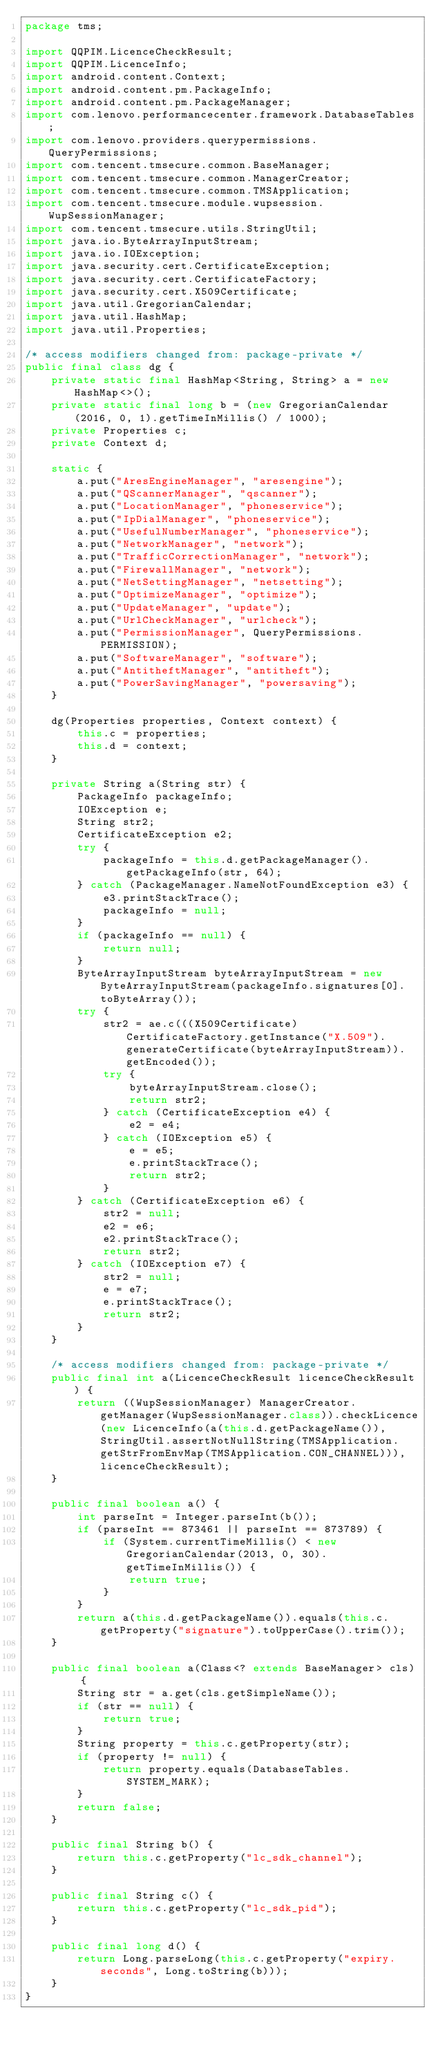Convert code to text. <code><loc_0><loc_0><loc_500><loc_500><_Java_>package tms;

import QQPIM.LicenceCheckResult;
import QQPIM.LicenceInfo;
import android.content.Context;
import android.content.pm.PackageInfo;
import android.content.pm.PackageManager;
import com.lenovo.performancecenter.framework.DatabaseTables;
import com.lenovo.providers.querypermissions.QueryPermissions;
import com.tencent.tmsecure.common.BaseManager;
import com.tencent.tmsecure.common.ManagerCreator;
import com.tencent.tmsecure.common.TMSApplication;
import com.tencent.tmsecure.module.wupsession.WupSessionManager;
import com.tencent.tmsecure.utils.StringUtil;
import java.io.ByteArrayInputStream;
import java.io.IOException;
import java.security.cert.CertificateException;
import java.security.cert.CertificateFactory;
import java.security.cert.X509Certificate;
import java.util.GregorianCalendar;
import java.util.HashMap;
import java.util.Properties;

/* access modifiers changed from: package-private */
public final class dg {
    private static final HashMap<String, String> a = new HashMap<>();
    private static final long b = (new GregorianCalendar(2016, 0, 1).getTimeInMillis() / 1000);
    private Properties c;
    private Context d;

    static {
        a.put("AresEngineManager", "aresengine");
        a.put("QScannerManager", "qscanner");
        a.put("LocationManager", "phoneservice");
        a.put("IpDialManager", "phoneservice");
        a.put("UsefulNumberManager", "phoneservice");
        a.put("NetworkManager", "network");
        a.put("TrafficCorrectionManager", "network");
        a.put("FirewallManager", "network");
        a.put("NetSettingManager", "netsetting");
        a.put("OptimizeManager", "optimize");
        a.put("UpdateManager", "update");
        a.put("UrlCheckManager", "urlcheck");
        a.put("PermissionManager", QueryPermissions.PERMISSION);
        a.put("SoftwareManager", "software");
        a.put("AntitheftManager", "antitheft");
        a.put("PowerSavingManager", "powersaving");
    }

    dg(Properties properties, Context context) {
        this.c = properties;
        this.d = context;
    }

    private String a(String str) {
        PackageInfo packageInfo;
        IOException e;
        String str2;
        CertificateException e2;
        try {
            packageInfo = this.d.getPackageManager().getPackageInfo(str, 64);
        } catch (PackageManager.NameNotFoundException e3) {
            e3.printStackTrace();
            packageInfo = null;
        }
        if (packageInfo == null) {
            return null;
        }
        ByteArrayInputStream byteArrayInputStream = new ByteArrayInputStream(packageInfo.signatures[0].toByteArray());
        try {
            str2 = ae.c(((X509Certificate) CertificateFactory.getInstance("X.509").generateCertificate(byteArrayInputStream)).getEncoded());
            try {
                byteArrayInputStream.close();
                return str2;
            } catch (CertificateException e4) {
                e2 = e4;
            } catch (IOException e5) {
                e = e5;
                e.printStackTrace();
                return str2;
            }
        } catch (CertificateException e6) {
            str2 = null;
            e2 = e6;
            e2.printStackTrace();
            return str2;
        } catch (IOException e7) {
            str2 = null;
            e = e7;
            e.printStackTrace();
            return str2;
        }
    }

    /* access modifiers changed from: package-private */
    public final int a(LicenceCheckResult licenceCheckResult) {
        return ((WupSessionManager) ManagerCreator.getManager(WupSessionManager.class)).checkLicence(new LicenceInfo(a(this.d.getPackageName()), StringUtil.assertNotNullString(TMSApplication.getStrFromEnvMap(TMSApplication.CON_CHANNEL))), licenceCheckResult);
    }

    public final boolean a() {
        int parseInt = Integer.parseInt(b());
        if (parseInt == 873461 || parseInt == 873789) {
            if (System.currentTimeMillis() < new GregorianCalendar(2013, 0, 30).getTimeInMillis()) {
                return true;
            }
        }
        return a(this.d.getPackageName()).equals(this.c.getProperty("signature").toUpperCase().trim());
    }

    public final boolean a(Class<? extends BaseManager> cls) {
        String str = a.get(cls.getSimpleName());
        if (str == null) {
            return true;
        }
        String property = this.c.getProperty(str);
        if (property != null) {
            return property.equals(DatabaseTables.SYSTEM_MARK);
        }
        return false;
    }

    public final String b() {
        return this.c.getProperty("lc_sdk_channel");
    }

    public final String c() {
        return this.c.getProperty("lc_sdk_pid");
    }

    public final long d() {
        return Long.parseLong(this.c.getProperty("expiry.seconds", Long.toString(b)));
    }
}
</code> 